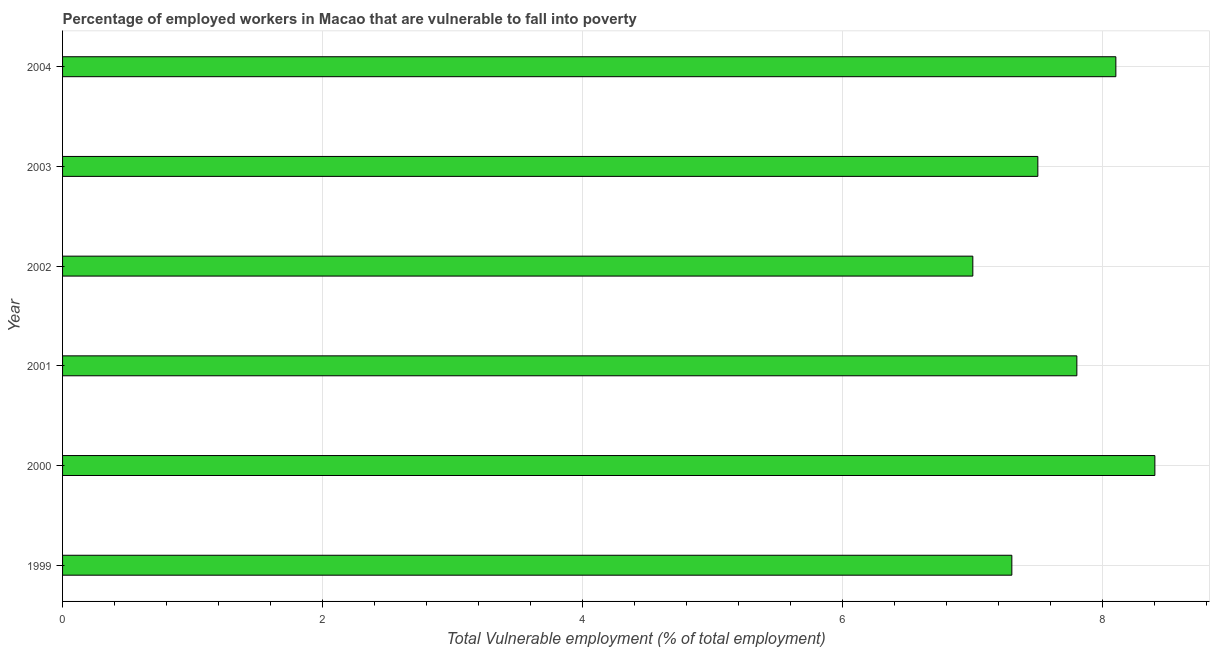Does the graph contain any zero values?
Your answer should be very brief. No. What is the title of the graph?
Offer a terse response. Percentage of employed workers in Macao that are vulnerable to fall into poverty. What is the label or title of the X-axis?
Your response must be concise. Total Vulnerable employment (% of total employment). What is the total vulnerable employment in 2001?
Your answer should be very brief. 7.8. Across all years, what is the maximum total vulnerable employment?
Your response must be concise. 8.4. Across all years, what is the minimum total vulnerable employment?
Your response must be concise. 7. What is the sum of the total vulnerable employment?
Give a very brief answer. 46.1. What is the average total vulnerable employment per year?
Offer a terse response. 7.68. What is the median total vulnerable employment?
Give a very brief answer. 7.65. Do a majority of the years between 2002 and 2004 (inclusive) have total vulnerable employment greater than 1.2 %?
Provide a succinct answer. Yes. What is the ratio of the total vulnerable employment in 1999 to that in 2003?
Offer a very short reply. 0.97. Is the total vulnerable employment in 1999 less than that in 2003?
Make the answer very short. Yes. Is the difference between the total vulnerable employment in 2001 and 2002 greater than the difference between any two years?
Provide a short and direct response. No. What is the difference between the highest and the second highest total vulnerable employment?
Offer a terse response. 0.3. What is the difference between the highest and the lowest total vulnerable employment?
Ensure brevity in your answer.  1.4. Are all the bars in the graph horizontal?
Your answer should be very brief. Yes. Are the values on the major ticks of X-axis written in scientific E-notation?
Ensure brevity in your answer.  No. What is the Total Vulnerable employment (% of total employment) in 1999?
Offer a very short reply. 7.3. What is the Total Vulnerable employment (% of total employment) in 2000?
Your answer should be compact. 8.4. What is the Total Vulnerable employment (% of total employment) of 2001?
Provide a succinct answer. 7.8. What is the Total Vulnerable employment (% of total employment) of 2004?
Your answer should be very brief. 8.1. What is the difference between the Total Vulnerable employment (% of total employment) in 1999 and 2001?
Your response must be concise. -0.5. What is the difference between the Total Vulnerable employment (% of total employment) in 1999 and 2003?
Your answer should be very brief. -0.2. What is the difference between the Total Vulnerable employment (% of total employment) in 1999 and 2004?
Ensure brevity in your answer.  -0.8. What is the difference between the Total Vulnerable employment (% of total employment) in 2000 and 2002?
Provide a succinct answer. 1.4. What is the difference between the Total Vulnerable employment (% of total employment) in 2000 and 2003?
Your response must be concise. 0.9. What is the difference between the Total Vulnerable employment (% of total employment) in 2001 and 2002?
Your response must be concise. 0.8. What is the difference between the Total Vulnerable employment (% of total employment) in 2002 and 2003?
Provide a short and direct response. -0.5. What is the ratio of the Total Vulnerable employment (% of total employment) in 1999 to that in 2000?
Keep it short and to the point. 0.87. What is the ratio of the Total Vulnerable employment (% of total employment) in 1999 to that in 2001?
Keep it short and to the point. 0.94. What is the ratio of the Total Vulnerable employment (% of total employment) in 1999 to that in 2002?
Offer a very short reply. 1.04. What is the ratio of the Total Vulnerable employment (% of total employment) in 1999 to that in 2003?
Provide a succinct answer. 0.97. What is the ratio of the Total Vulnerable employment (% of total employment) in 1999 to that in 2004?
Your response must be concise. 0.9. What is the ratio of the Total Vulnerable employment (% of total employment) in 2000 to that in 2001?
Your answer should be compact. 1.08. What is the ratio of the Total Vulnerable employment (% of total employment) in 2000 to that in 2002?
Make the answer very short. 1.2. What is the ratio of the Total Vulnerable employment (% of total employment) in 2000 to that in 2003?
Offer a terse response. 1.12. What is the ratio of the Total Vulnerable employment (% of total employment) in 2001 to that in 2002?
Keep it short and to the point. 1.11. What is the ratio of the Total Vulnerable employment (% of total employment) in 2001 to that in 2003?
Keep it short and to the point. 1.04. What is the ratio of the Total Vulnerable employment (% of total employment) in 2001 to that in 2004?
Your response must be concise. 0.96. What is the ratio of the Total Vulnerable employment (% of total employment) in 2002 to that in 2003?
Make the answer very short. 0.93. What is the ratio of the Total Vulnerable employment (% of total employment) in 2002 to that in 2004?
Your response must be concise. 0.86. What is the ratio of the Total Vulnerable employment (% of total employment) in 2003 to that in 2004?
Offer a very short reply. 0.93. 